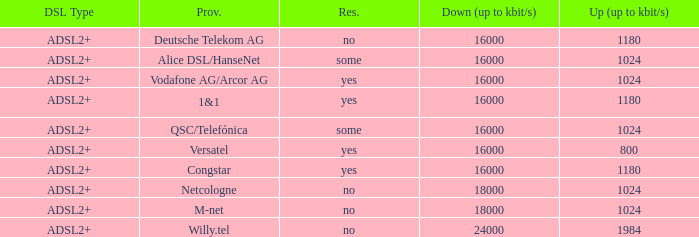Who are all of the telecom providers for which the upload rate is 1024 kbits and the resale category is yes? Vodafone AG/Arcor AG. Parse the table in full. {'header': ['DSL Type', 'Prov.', 'Res.', 'Down (up to kbit/s)', 'Up (up to kbit/s)'], 'rows': [['ADSL2+', 'Deutsche Telekom AG', 'no', '16000', '1180'], ['ADSL2+', 'Alice DSL/HanseNet', 'some', '16000', '1024'], ['ADSL2+', 'Vodafone AG/Arcor AG', 'yes', '16000', '1024'], ['ADSL2+', '1&1', 'yes', '16000', '1180'], ['ADSL2+', 'QSC/Telefónica', 'some', '16000', '1024'], ['ADSL2+', 'Versatel', 'yes', '16000', '800'], ['ADSL2+', 'Congstar', 'yes', '16000', '1180'], ['ADSL2+', 'Netcologne', 'no', '18000', '1024'], ['ADSL2+', 'M-net', 'no', '18000', '1024'], ['ADSL2+', 'Willy.tel', 'no', '24000', '1984']]} 